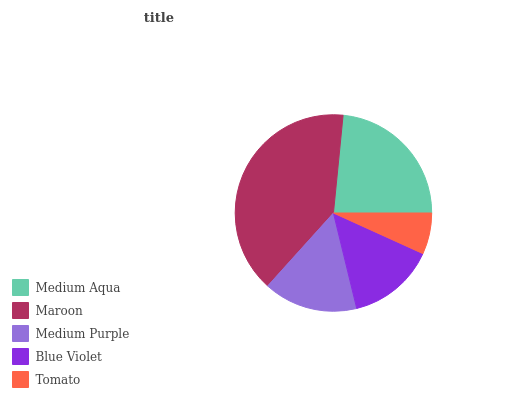Is Tomato the minimum?
Answer yes or no. Yes. Is Maroon the maximum?
Answer yes or no. Yes. Is Medium Purple the minimum?
Answer yes or no. No. Is Medium Purple the maximum?
Answer yes or no. No. Is Maroon greater than Medium Purple?
Answer yes or no. Yes. Is Medium Purple less than Maroon?
Answer yes or no. Yes. Is Medium Purple greater than Maroon?
Answer yes or no. No. Is Maroon less than Medium Purple?
Answer yes or no. No. Is Medium Purple the high median?
Answer yes or no. Yes. Is Medium Purple the low median?
Answer yes or no. Yes. Is Medium Aqua the high median?
Answer yes or no. No. Is Maroon the low median?
Answer yes or no. No. 